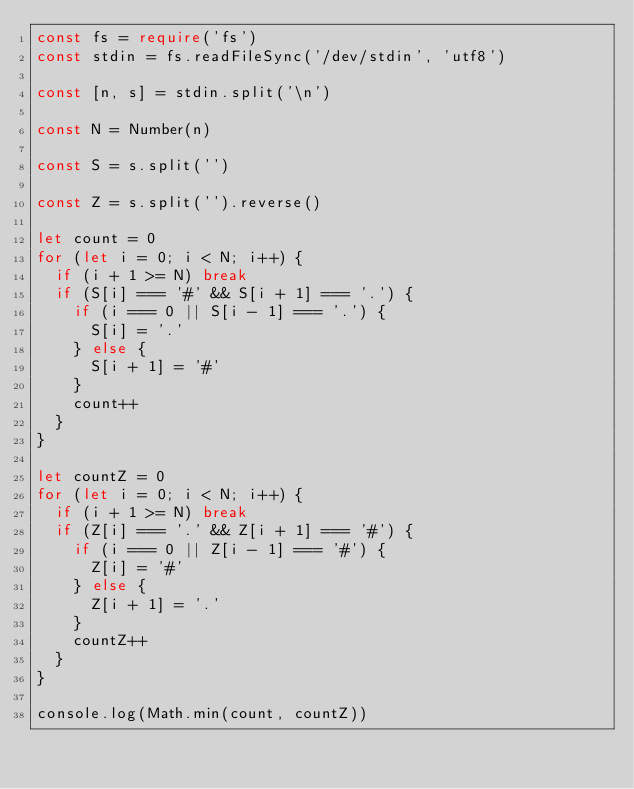Convert code to text. <code><loc_0><loc_0><loc_500><loc_500><_TypeScript_>const fs = require('fs')
const stdin = fs.readFileSync('/dev/stdin', 'utf8')

const [n, s] = stdin.split('\n')

const N = Number(n)

const S = s.split('')

const Z = s.split('').reverse()

let count = 0
for (let i = 0; i < N; i++) {
  if (i + 1 >= N) break
  if (S[i] === '#' && S[i + 1] === '.') {
    if (i === 0 || S[i - 1] === '.') {
      S[i] = '.'
    } else {
      S[i + 1] = '#'
    }
    count++
  }
}

let countZ = 0
for (let i = 0; i < N; i++) {
  if (i + 1 >= N) break
  if (Z[i] === '.' && Z[i + 1] === '#') {
    if (i === 0 || Z[i - 1] === '#') {
      Z[i] = '#'
    } else {
      Z[i + 1] = '.'
    }
    countZ++
  }
}

console.log(Math.min(count, countZ))
</code> 